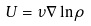<formula> <loc_0><loc_0><loc_500><loc_500>U = \nu \nabla \ln \rho</formula> 